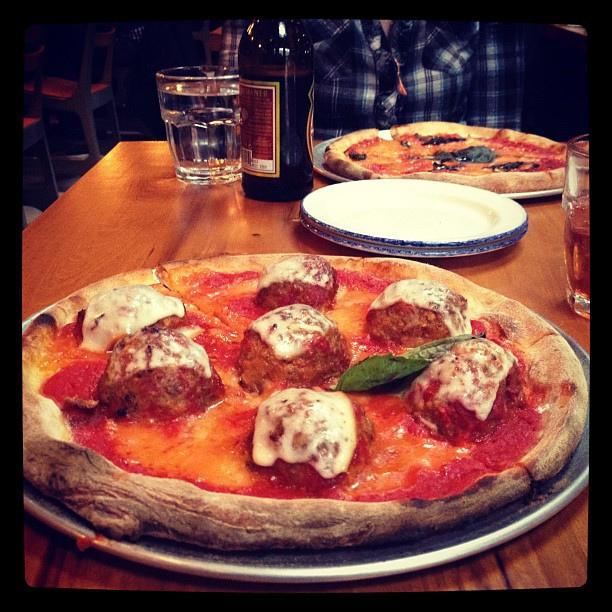How many people are dining?
Concise answer only. 2. Is this an Italian restaurant?
Write a very short answer. Yes. What is the topping on the pizza?
Short answer required. Meatballs. 